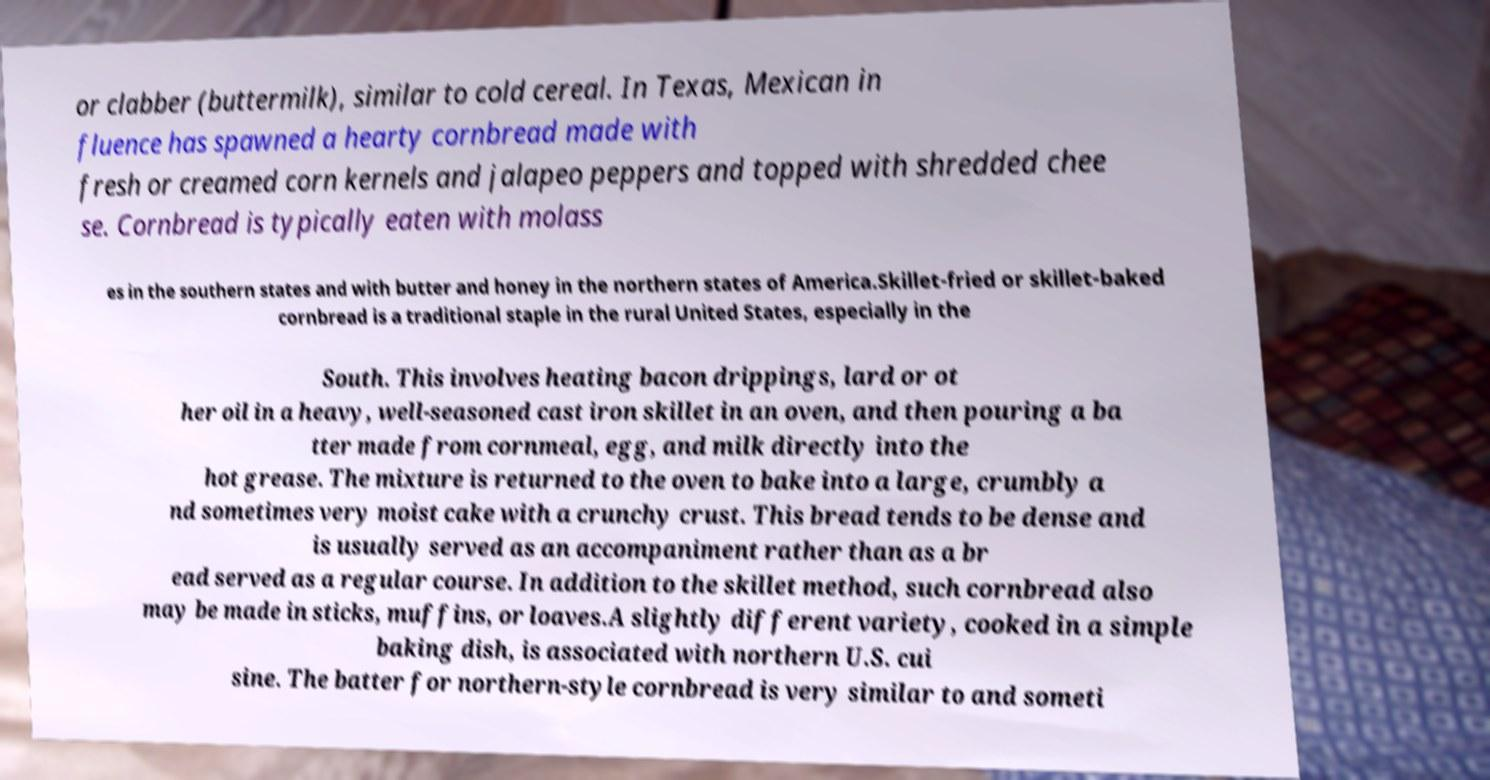Please identify and transcribe the text found in this image. or clabber (buttermilk), similar to cold cereal. In Texas, Mexican in fluence has spawned a hearty cornbread made with fresh or creamed corn kernels and jalapeo peppers and topped with shredded chee se. Cornbread is typically eaten with molass es in the southern states and with butter and honey in the northern states of America.Skillet-fried or skillet-baked cornbread is a traditional staple in the rural United States, especially in the South. This involves heating bacon drippings, lard or ot her oil in a heavy, well-seasoned cast iron skillet in an oven, and then pouring a ba tter made from cornmeal, egg, and milk directly into the hot grease. The mixture is returned to the oven to bake into a large, crumbly a nd sometimes very moist cake with a crunchy crust. This bread tends to be dense and is usually served as an accompaniment rather than as a br ead served as a regular course. In addition to the skillet method, such cornbread also may be made in sticks, muffins, or loaves.A slightly different variety, cooked in a simple baking dish, is associated with northern U.S. cui sine. The batter for northern-style cornbread is very similar to and someti 